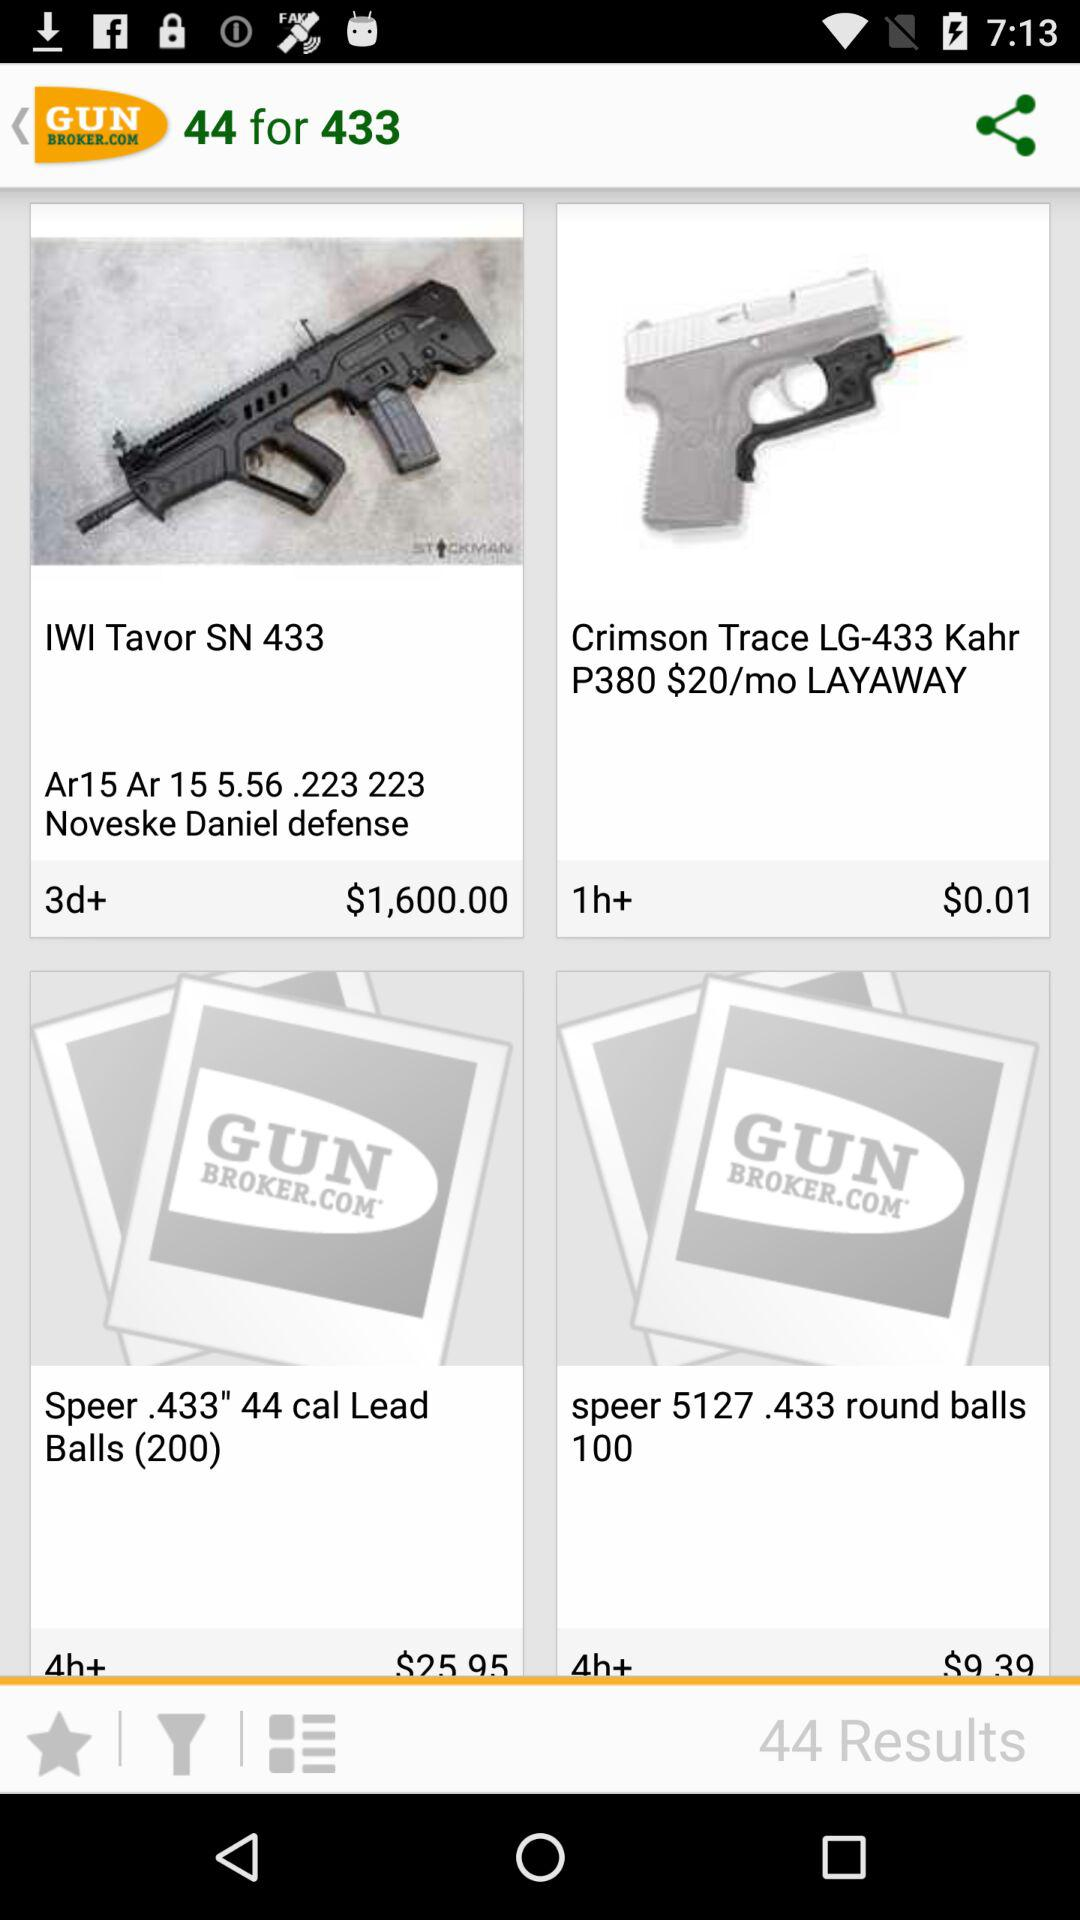What is the cost of speer 44 cal lead balls?
When the provided information is insufficient, respond with <no answer>. <no answer> 